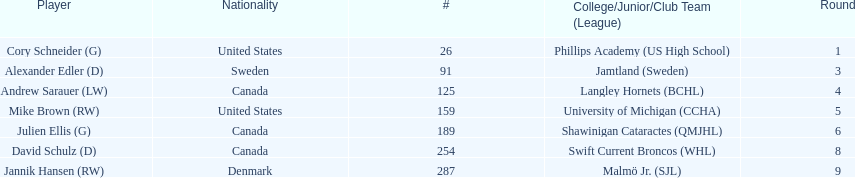What number of players have canada listed as their nationality? 3. 